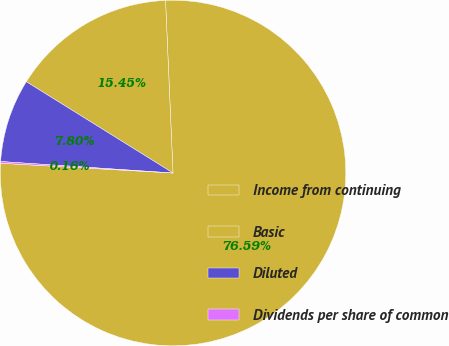<chart> <loc_0><loc_0><loc_500><loc_500><pie_chart><fcel>Income from continuing<fcel>Basic<fcel>Diluted<fcel>Dividends per share of common<nl><fcel>76.59%<fcel>15.45%<fcel>7.8%<fcel>0.16%<nl></chart> 